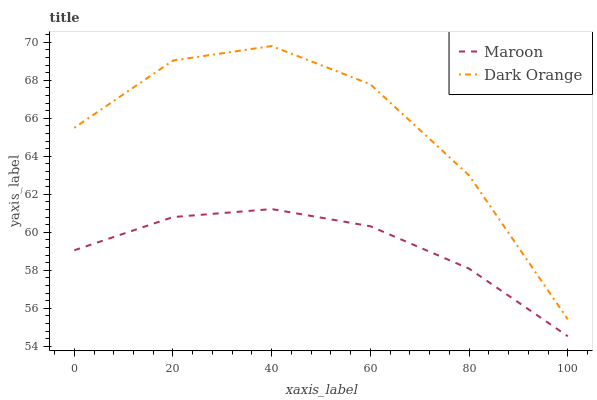Does Maroon have the minimum area under the curve?
Answer yes or no. Yes. Does Dark Orange have the maximum area under the curve?
Answer yes or no. Yes. Does Maroon have the maximum area under the curve?
Answer yes or no. No. Is Maroon the smoothest?
Answer yes or no. Yes. Is Dark Orange the roughest?
Answer yes or no. Yes. Is Maroon the roughest?
Answer yes or no. No. Does Dark Orange have the highest value?
Answer yes or no. Yes. Does Maroon have the highest value?
Answer yes or no. No. Is Maroon less than Dark Orange?
Answer yes or no. Yes. Is Dark Orange greater than Maroon?
Answer yes or no. Yes. Does Maroon intersect Dark Orange?
Answer yes or no. No. 